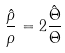Convert formula to latex. <formula><loc_0><loc_0><loc_500><loc_500>\frac { \hat { \rho } } { \rho } = 2 \frac { \hat { \Theta } } { \Theta }</formula> 